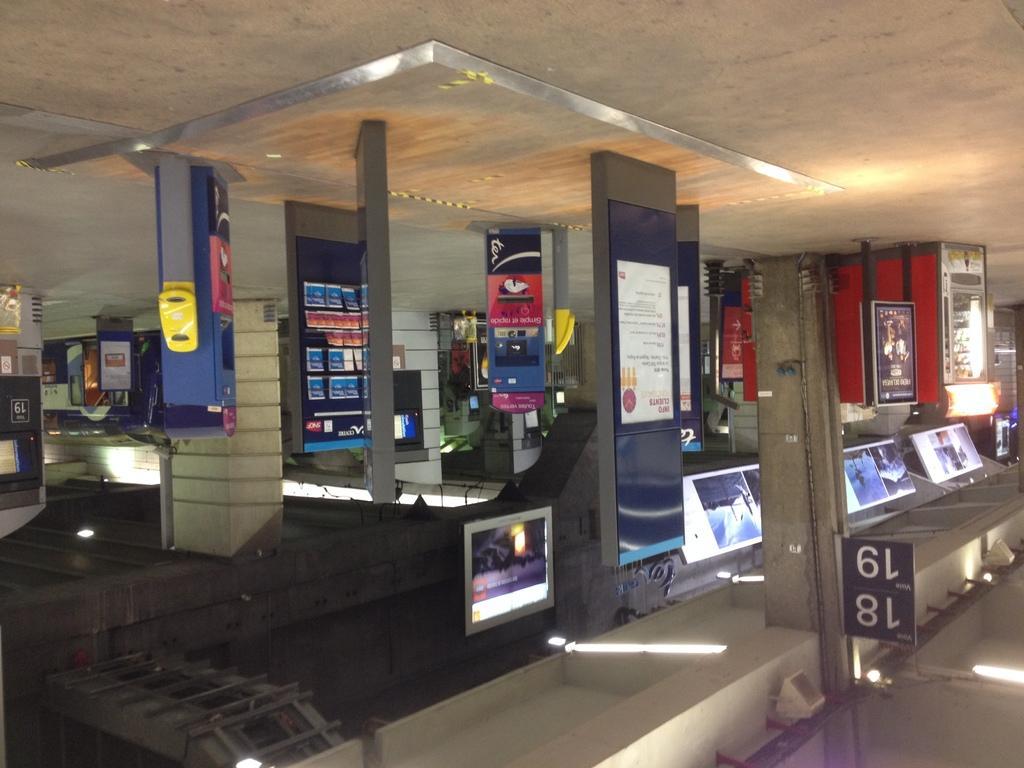Can you describe this image briefly? In the center of the picture there are boards, televisions, chairs and lights. At the top it is floor. At the bottom it is ceiling and there are lights to the ceiling. 